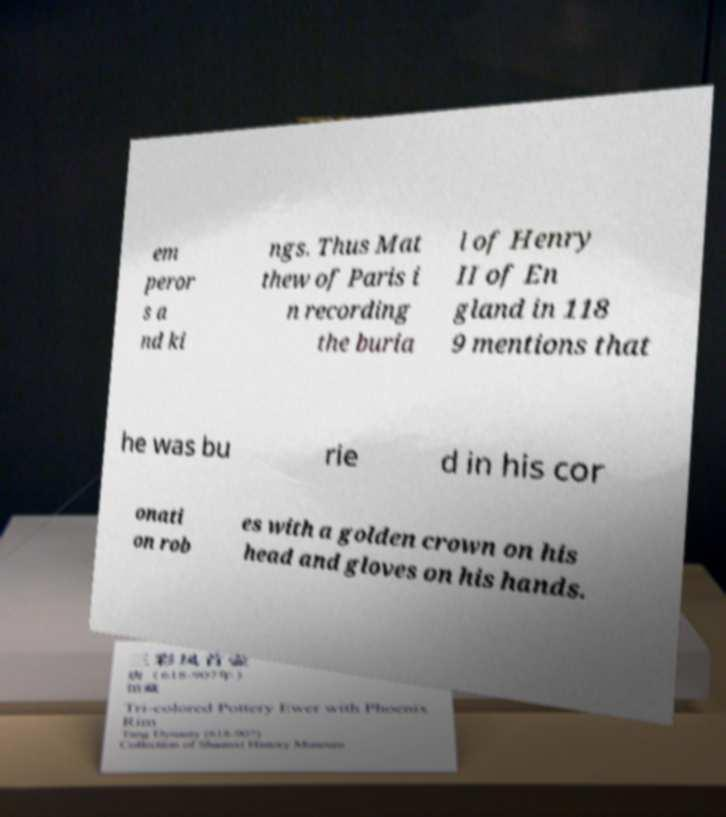Could you extract and type out the text from this image? em peror s a nd ki ngs. Thus Mat thew of Paris i n recording the buria l of Henry II of En gland in 118 9 mentions that he was bu rie d in his cor onati on rob es with a golden crown on his head and gloves on his hands. 